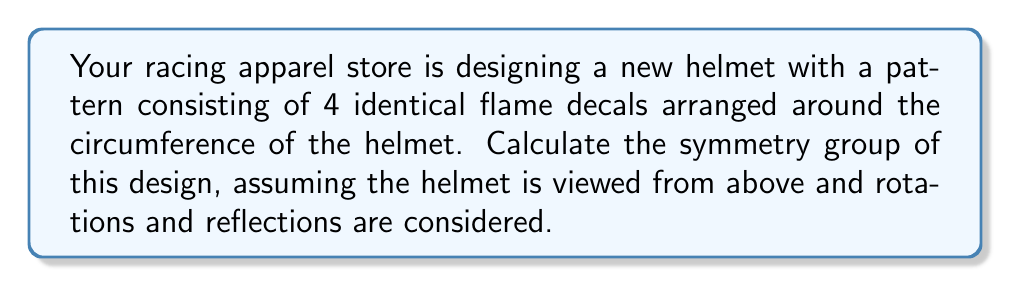Can you solve this math problem? To determine the symmetry group of the racing helmet design, we need to consider all the rotations and reflections that leave the pattern unchanged. Let's approach this step-by-step:

1) Rotational symmetries:
   - The design has 4 identical flame decals.
   - It can be rotated by 90°, 180°, 270°, and 360° (which is equivalent to 0°) to return to an identical configuration.
   - This gives us 4 rotational symmetries, including the identity rotation.

2) Reflection symmetries:
   - There are 4 lines of reflection: 2 passing through the centers of opposite flames, and 2 passing between adjacent flames.
   - This gives us 4 reflection symmetries.

3) Total number of symmetries:
   - We have 4 rotational symmetries and 4 reflection symmetries.
   - The total number of symmetries is 4 + 4 = 8.

4) Identifying the symmetry group:
   - The group has 8 elements.
   - It contains rotations by multiples of 90° and reflections.
   - This structure matches the dihedral group $D_4$.

5) Properties of $D_4$:
   - $D_4$ is the symmetry group of a square.
   - It has 8 elements: 4 rotations and 4 reflections.
   - Its order is 8: $|D_4| = 8$.

Therefore, the symmetry group of the racing helmet design is isomorphic to the dihedral group $D_4$.
Answer: $D_4$ 